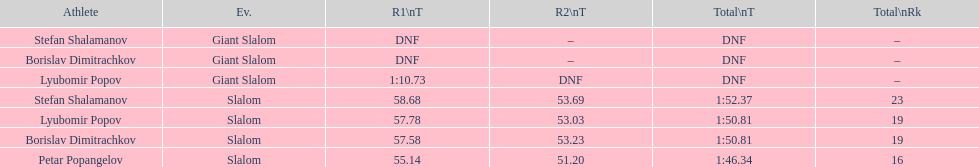Who was the other athlete who tied in rank with lyubomir popov? Borislav Dimitrachkov. Parse the full table. {'header': ['Athlete', 'Ev.', 'R1\\nT', 'R2\\nT', 'Total\\nT', 'Total\\nRk'], 'rows': [['Stefan Shalamanov', 'Giant Slalom', 'DNF', '–', 'DNF', '–'], ['Borislav Dimitrachkov', 'Giant Slalom', 'DNF', '–', 'DNF', '–'], ['Lyubomir Popov', 'Giant Slalom', '1:10.73', 'DNF', 'DNF', '–'], ['Stefan Shalamanov', 'Slalom', '58.68', '53.69', '1:52.37', '23'], ['Lyubomir Popov', 'Slalom', '57.78', '53.03', '1:50.81', '19'], ['Borislav Dimitrachkov', 'Slalom', '57.58', '53.23', '1:50.81', '19'], ['Petar Popangelov', 'Slalom', '55.14', '51.20', '1:46.34', '16']]} 